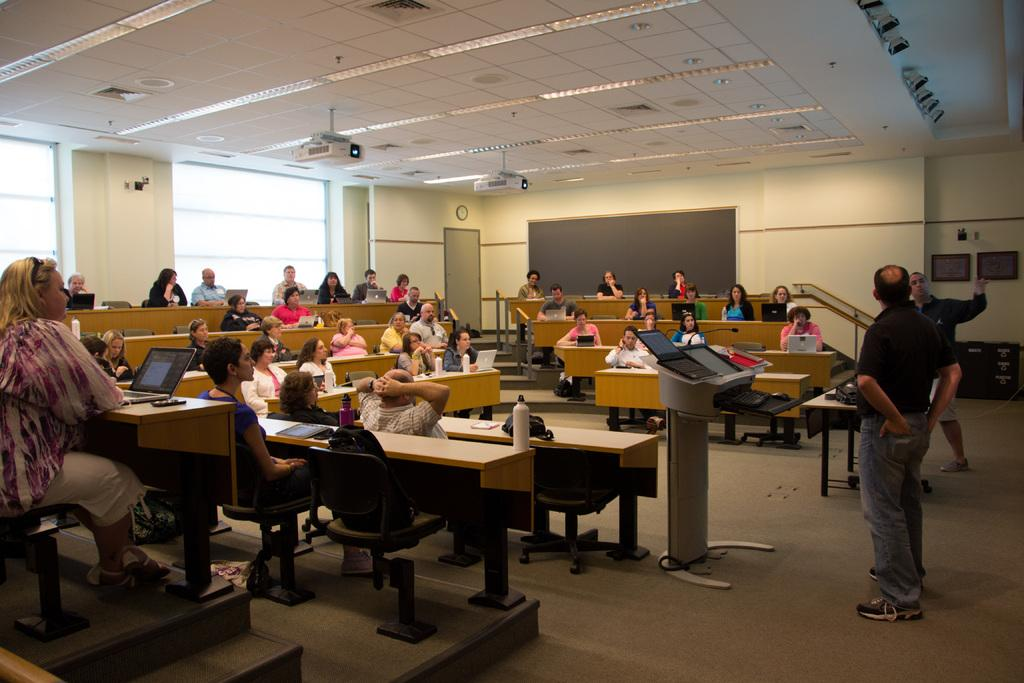What are the people in the image doing? There is a group of people sitting in the image, and they are using a laptop. Are there any other people in the image besides the group sitting? Yes, there are two people standing in the image. How does the group of people show respect to the wilderness in the image? There is no mention of wilderness in the image, and the group of people is using a laptop, not interacting with any natural environment. 